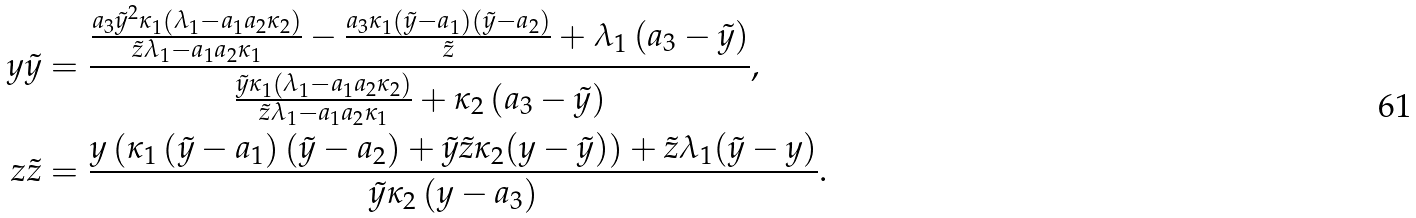<formula> <loc_0><loc_0><loc_500><loc_500>y \tilde { y } & = \frac { \frac { a _ { 3 } \tilde { y } ^ { 2 } \kappa _ { 1 } \left ( \lambda _ { 1 } - a _ { 1 } a _ { 2 } \kappa _ { 2 } \right ) } { \tilde { z } \lambda _ { 1 } - a _ { 1 } a _ { 2 } \kappa _ { 1 } } - \frac { a _ { 3 } \kappa _ { 1 } \left ( \tilde { y } - a _ { 1 } \right ) \left ( \tilde { y } - a _ { 2 } \right ) } { \tilde { z } } + \lambda _ { 1 } \left ( a _ { 3 } - \tilde { y } \right ) } { \frac { \tilde { y } \kappa _ { 1 } \left ( \lambda _ { 1 } - a _ { 1 } a _ { 2 } \kappa _ { 2 } \right ) } { \tilde { z } \lambda _ { 1 } - a _ { 1 } a _ { 2 } \kappa _ { 1 } } + \kappa _ { 2 } \left ( a _ { 3 } - \tilde { y } \right ) } , \\ z \tilde { z } & = \frac { y \left ( \kappa _ { 1 } \left ( \tilde { y } - a _ { 1 } \right ) \left ( \tilde { y } - a _ { 2 } \right ) + \tilde { y } \tilde { z } \kappa _ { 2 } ( y - \tilde { y } ) \right ) + \tilde { z } \lambda _ { 1 } ( \tilde { y } - y ) } { \tilde { y } \kappa _ { 2 } \left ( y - a _ { 3 } \right ) } .</formula> 